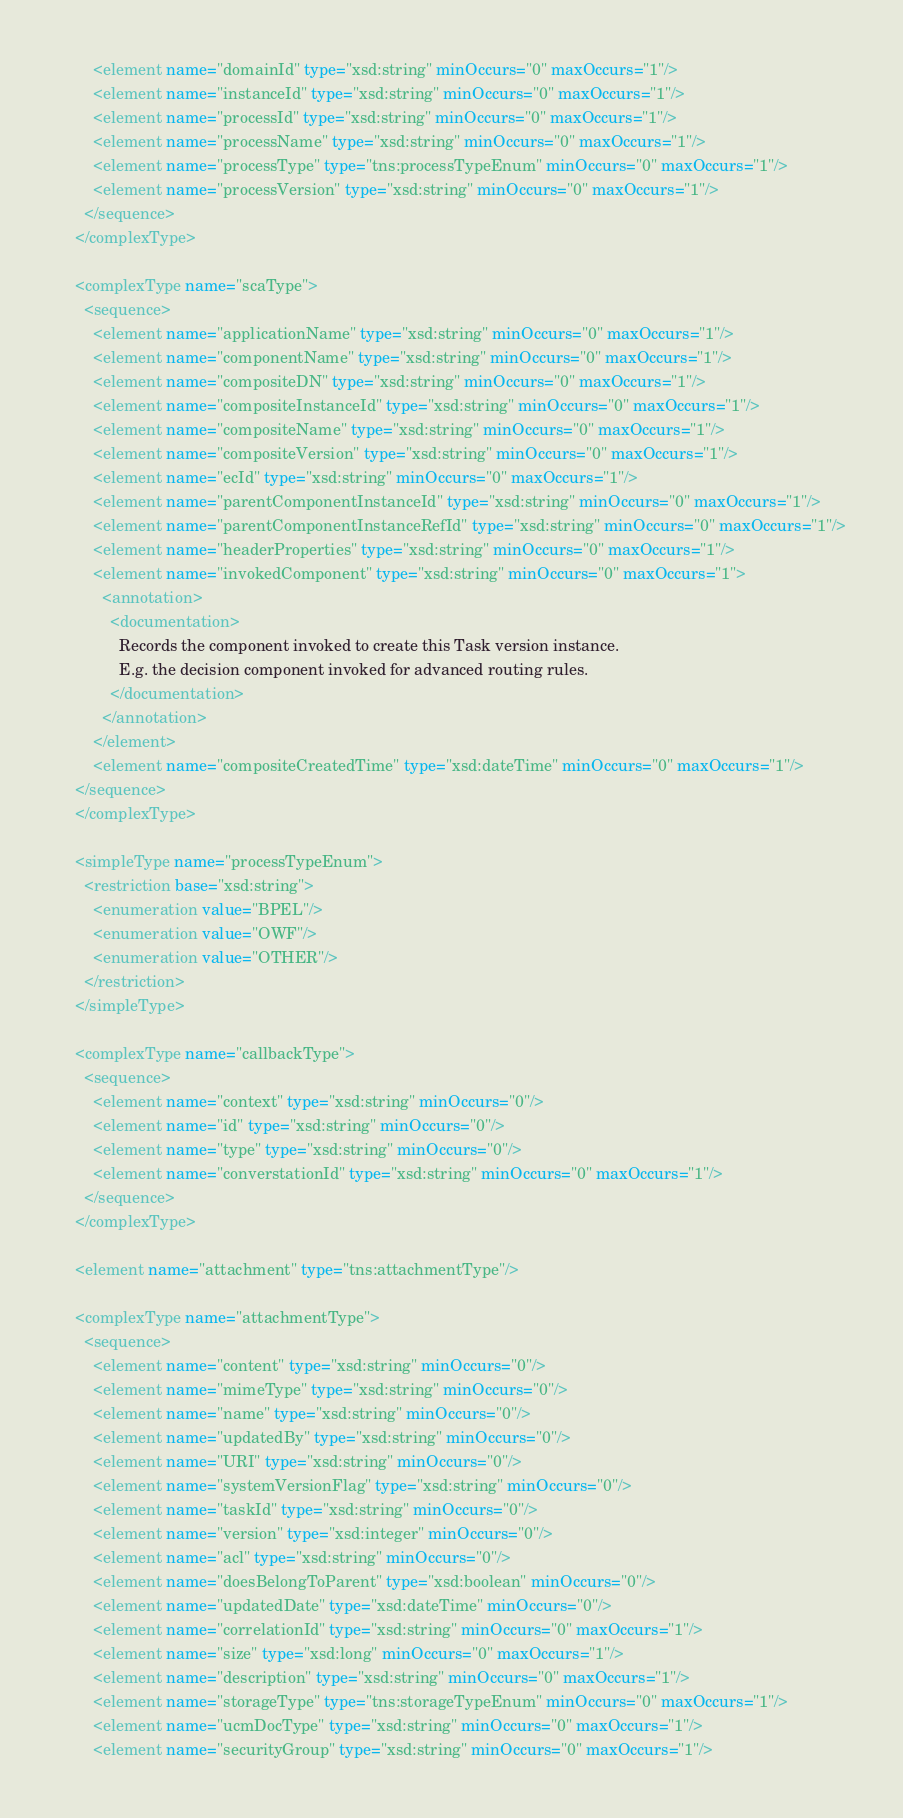<code> <loc_0><loc_0><loc_500><loc_500><_XML_>        <element name="domainId" type="xsd:string" minOccurs="0" maxOccurs="1"/>
        <element name="instanceId" type="xsd:string" minOccurs="0" maxOccurs="1"/>
        <element name="processId" type="xsd:string" minOccurs="0" maxOccurs="1"/>
        <element name="processName" type="xsd:string" minOccurs="0" maxOccurs="1"/>
        <element name="processType" type="tns:processTypeEnum" minOccurs="0" maxOccurs="1"/>
        <element name="processVersion" type="xsd:string" minOccurs="0" maxOccurs="1"/>
      </sequence>
    </complexType>

    <complexType name="scaType">
      <sequence>
        <element name="applicationName" type="xsd:string" minOccurs="0" maxOccurs="1"/>
        <element name="componentName" type="xsd:string" minOccurs="0" maxOccurs="1"/>
        <element name="compositeDN" type="xsd:string" minOccurs="0" maxOccurs="1"/>
        <element name="compositeInstanceId" type="xsd:string" minOccurs="0" maxOccurs="1"/>
        <element name="compositeName" type="xsd:string" minOccurs="0" maxOccurs="1"/>
        <element name="compositeVersion" type="xsd:string" minOccurs="0" maxOccurs="1"/>
        <element name="ecId" type="xsd:string" minOccurs="0" maxOccurs="1"/>
        <element name="parentComponentInstanceId" type="xsd:string" minOccurs="0" maxOccurs="1"/>
        <element name="parentComponentInstanceRefId" type="xsd:string" minOccurs="0" maxOccurs="1"/>
        <element name="headerProperties" type="xsd:string" minOccurs="0" maxOccurs="1"/>
        <element name="invokedComponent" type="xsd:string" minOccurs="0" maxOccurs="1">        
          <annotation>
            <documentation>
              Records the component invoked to create this Task version instance.
              E.g. the decision component invoked for advanced routing rules.
            </documentation>
          </annotation>
        </element>
        <element name="compositeCreatedTime" type="xsd:dateTime" minOccurs="0" maxOccurs="1"/>
    </sequence>
    </complexType>

    <simpleType name="processTypeEnum">
      <restriction base="xsd:string">
        <enumeration value="BPEL"/>
        <enumeration value="OWF"/>
        <enumeration value="OTHER"/>
      </restriction>
    </simpleType>

    <complexType name="callbackType">
      <sequence>
        <element name="context" type="xsd:string" minOccurs="0"/>
        <element name="id" type="xsd:string" minOccurs="0"/>
        <element name="type" type="xsd:string" minOccurs="0"/>
        <element name="converstationId" type="xsd:string" minOccurs="0" maxOccurs="1"/>
      </sequence>
    </complexType>

    <element name="attachment" type="tns:attachmentType"/>

    <complexType name="attachmentType">
      <sequence>
        <element name="content" type="xsd:string" minOccurs="0"/>
        <element name="mimeType" type="xsd:string" minOccurs="0"/>
        <element name="name" type="xsd:string" minOccurs="0"/>
        <element name="updatedBy" type="xsd:string" minOccurs="0"/>
        <element name="URI" type="xsd:string" minOccurs="0"/>
        <element name="systemVersionFlag" type="xsd:string" minOccurs="0"/>
        <element name="taskId" type="xsd:string" minOccurs="0"/>
        <element name="version" type="xsd:integer" minOccurs="0"/>
        <element name="acl" type="xsd:string" minOccurs="0"/>
        <element name="doesBelongToParent" type="xsd:boolean" minOccurs="0"/>
        <element name="updatedDate" type="xsd:dateTime" minOccurs="0"/>
        <element name="correlationId" type="xsd:string" minOccurs="0" maxOccurs="1"/>
        <element name="size" type="xsd:long" minOccurs="0" maxOccurs="1"/>
        <element name="description" type="xsd:string" minOccurs="0" maxOccurs="1"/>
        <element name="storageType" type="tns:storageTypeEnum" minOccurs="0" maxOccurs="1"/>
        <element name="ucmDocType" type="xsd:string" minOccurs="0" maxOccurs="1"/>
        <element name="securityGroup" type="xsd:string" minOccurs="0" maxOccurs="1"/></code> 